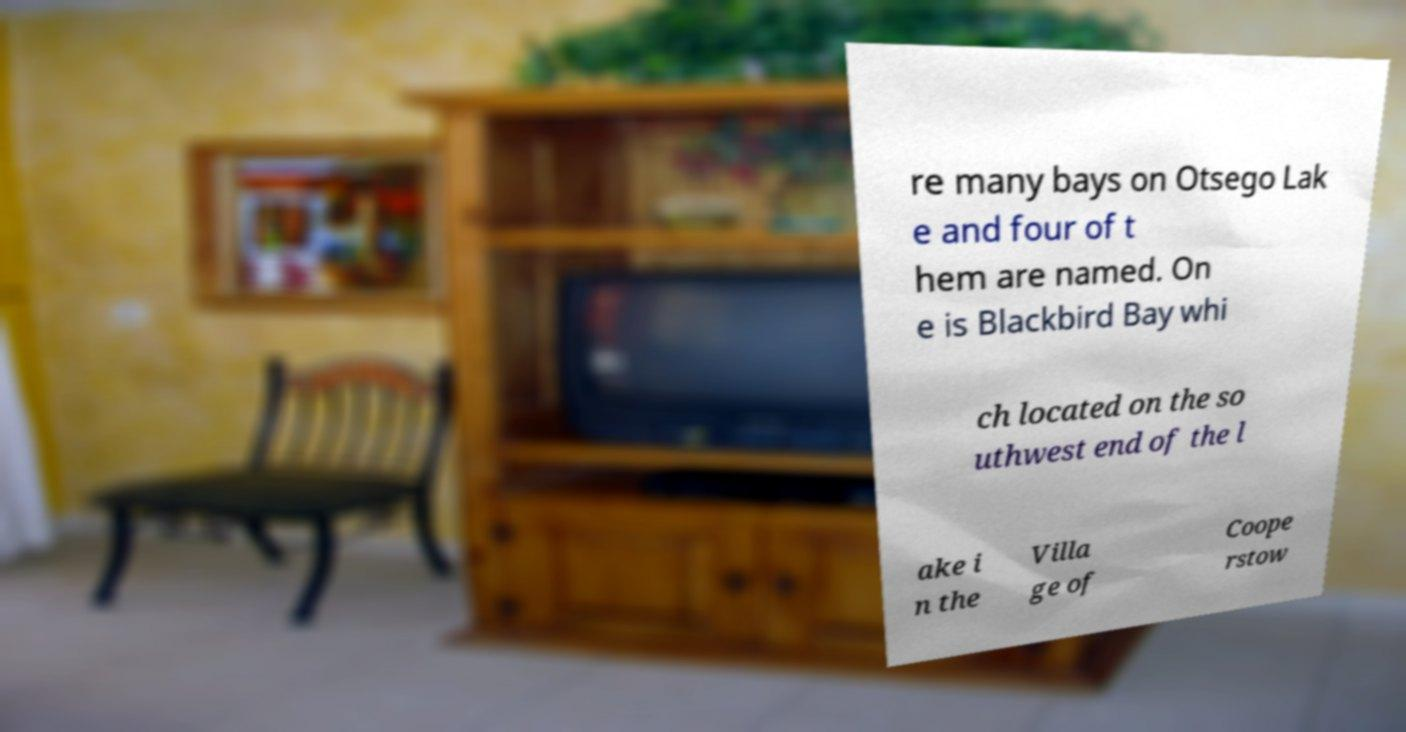Can you accurately transcribe the text from the provided image for me? re many bays on Otsego Lak e and four of t hem are named. On e is Blackbird Bay whi ch located on the so uthwest end of the l ake i n the Villa ge of Coope rstow 